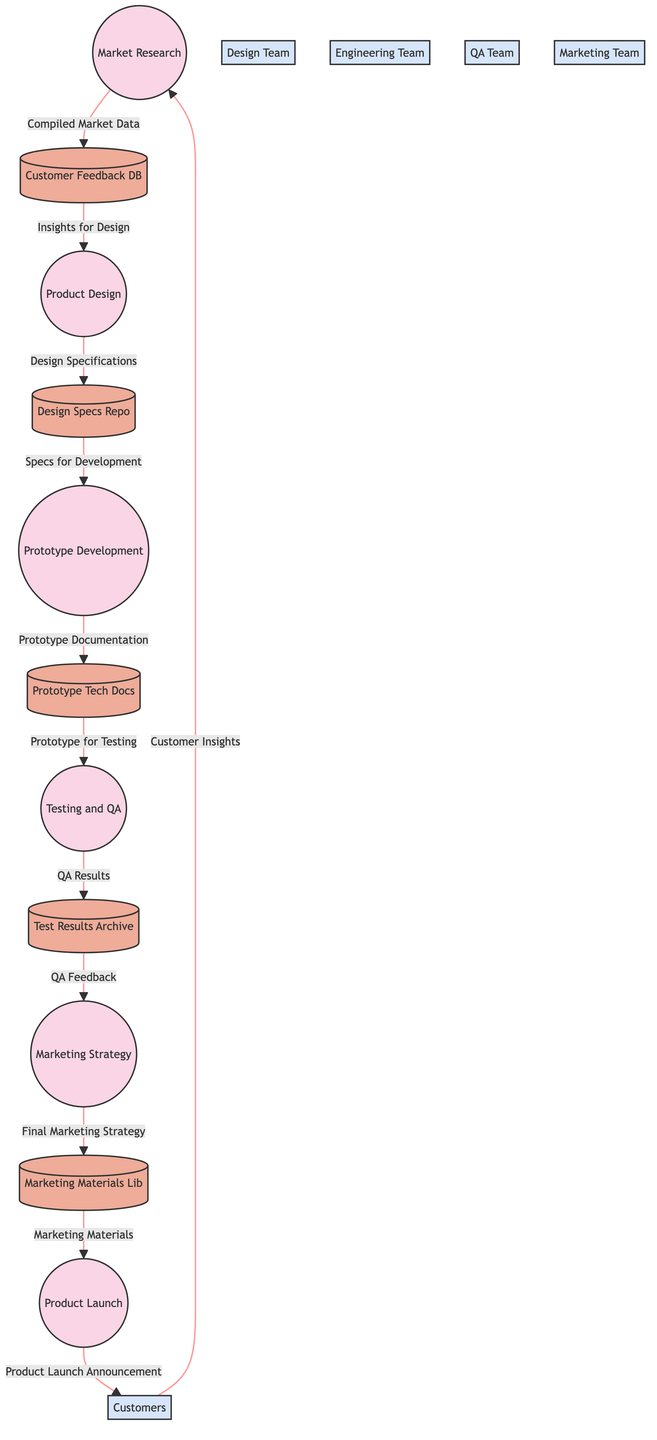What is the first process in the diagram? The first process is indicated as "1" in the diagram, which corresponds to "Market Research."
Answer: Market Research How many data stores are present in the diagram? The diagram lists five data stores, each labeled with unique identifiers and names.
Answer: 5 Which external entity provides customer insights to the market research process? The external entity "EE1" labeled as "Customers" is the one providing insights to process "1" (Market Research).
Answer: Customers What does the product design process output as its specification? The product design process outputs "Design Specifications," which is directed towards data store "DS2."
Answer: Design Specifications Which team receives QA feedback after testing? The QA feedback is sent to process "5," which corresponds to the Marketing Strategy team, as indicated by the arrows in the diagram.
Answer: Marketing Strategy Explain the flow of data from customers to the product launch announcement. The flow begins with "Customer Insights" from Customers (EE1) to Market Research (process 1), which compiles this into "Compiled Market Data" sent to Customer Feedback Database (DS1). Next, insights from DS1 are directed to the Product Design process (process 2), resulting in "Design Specifications" sent to the Design Specs Repository (DS2), followed by specifications for development directed to Prototype Development (process 3). This leads to "Prototype Documentation" in Prototype Tech Docs (DS3), which the Testing and QA process (process 4) uses to provide "QA Results" stored in Test Results Archive (DS4). These results turn into "QA Feedback" sent to Marketing Strategy (process 5), ultimately producing "Marketing Materials" for the Product Launch (process 6). Finally, a "Product Launch Announcement" is sent to Customers (EE1).
Answer: Customers to Product Launch Announcement flow How is customer feedback utilized in the diagram? Customer feedback is compiled into market data during the Market Research process, which is then used as insights for the Product Design process. This signifies that customer feedback is integral to the initial stages of the product development lifecycle.
Answer: As insights for design What is the final output of the product launch process? The final output from the Product Launch process (6) is a "Product Launch Announcement" directed to the Customers external entity (EE1).
Answer: Product Launch Announcement How many processes are linked to data store DS4? Data store "DS4 (Test Results Archive)" receives inputs from process "4" for "QA Results" and provides outputs to process "5" for "QA Feedback," leading to its total links being two.
Answer: 2 